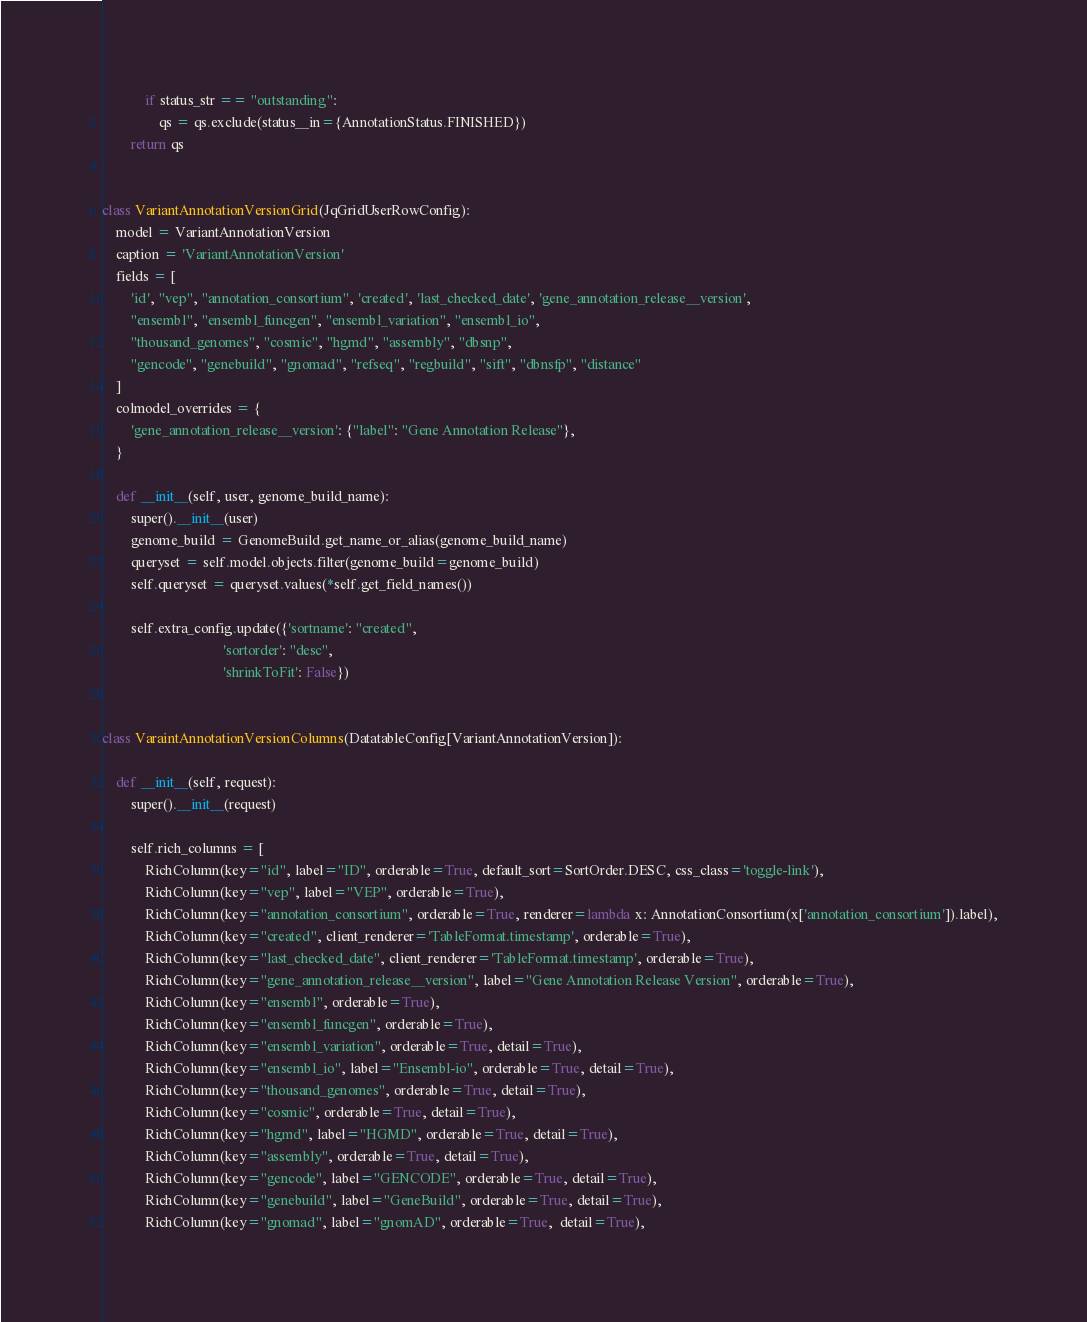Convert code to text. <code><loc_0><loc_0><loc_500><loc_500><_Python_>            if status_str == "outstanding":
                qs = qs.exclude(status__in={AnnotationStatus.FINISHED})
        return qs


class VariantAnnotationVersionGrid(JqGridUserRowConfig):
    model = VariantAnnotationVersion
    caption = 'VariantAnnotationVersion'
    fields = [
        'id', "vep", "annotation_consortium", 'created', 'last_checked_date', 'gene_annotation_release__version',
        "ensembl", "ensembl_funcgen", "ensembl_variation", "ensembl_io",
        "thousand_genomes", "cosmic", "hgmd", "assembly", "dbsnp",
        "gencode", "genebuild", "gnomad", "refseq", "regbuild", "sift", "dbnsfp", "distance"
    ]
    colmodel_overrides = {
        'gene_annotation_release__version': {"label": "Gene Annotation Release"},
    }

    def __init__(self, user, genome_build_name):
        super().__init__(user)
        genome_build = GenomeBuild.get_name_or_alias(genome_build_name)
        queryset = self.model.objects.filter(genome_build=genome_build)
        self.queryset = queryset.values(*self.get_field_names())

        self.extra_config.update({'sortname': "created",
                                  'sortorder': "desc",
                                  'shrinkToFit': False})


class VaraintAnnotationVersionColumns(DatatableConfig[VariantAnnotationVersion]):

    def __init__(self, request):
        super().__init__(request)

        self.rich_columns = [
            RichColumn(key="id", label="ID", orderable=True, default_sort=SortOrder.DESC, css_class='toggle-link'),
            RichColumn(key="vep", label="VEP", orderable=True),
            RichColumn(key="annotation_consortium", orderable=True, renderer=lambda x: AnnotationConsortium(x['annotation_consortium']).label),
            RichColumn(key="created", client_renderer='TableFormat.timestamp', orderable=True),
            RichColumn(key="last_checked_date", client_renderer='TableFormat.timestamp', orderable=True),
            RichColumn(key="gene_annotation_release__version", label="Gene Annotation Release Version", orderable=True),
            RichColumn(key="ensembl", orderable=True),
            RichColumn(key="ensembl_funcgen", orderable=True),
            RichColumn(key="ensembl_variation", orderable=True, detail=True),
            RichColumn(key="ensembl_io", label="Ensembl-io", orderable=True, detail=True),
            RichColumn(key="thousand_genomes", orderable=True, detail=True),
            RichColumn(key="cosmic", orderable=True, detail=True),
            RichColumn(key="hgmd", label="HGMD", orderable=True, detail=True),
            RichColumn(key="assembly", orderable=True, detail=True),
            RichColumn(key="gencode", label="GENCODE", orderable=True, detail=True),
            RichColumn(key="genebuild", label="GeneBuild", orderable=True, detail=True),
            RichColumn(key="gnomad", label="gnomAD", orderable=True,  detail=True),</code> 